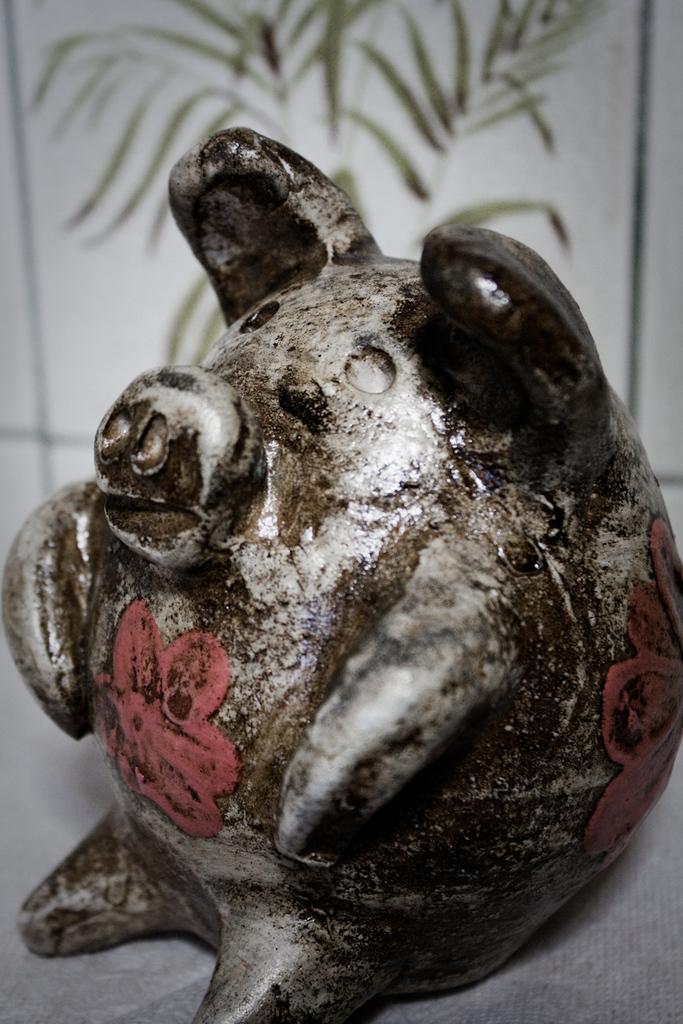Could you give a brief overview of what you see in this image? In this image, we can see a sculpture. In the background, image is blurred. 